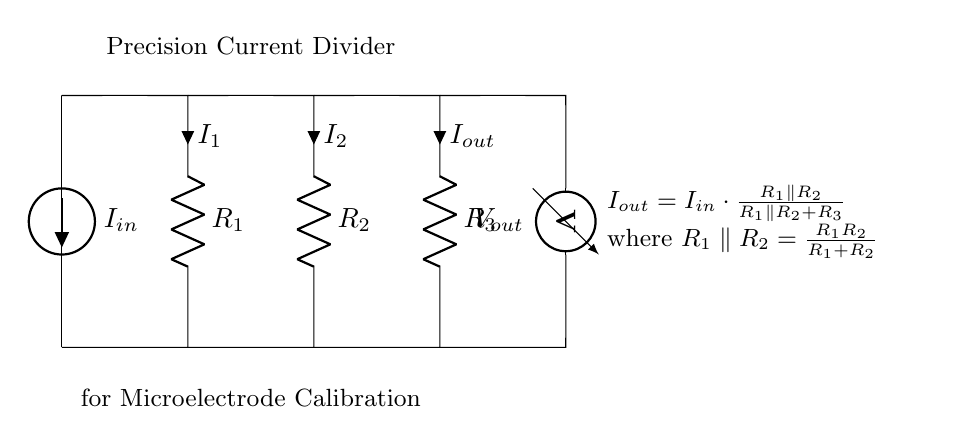What type of current source is used in this circuit? The circuit uses an American current source, as indicated by the symbol and label in the diagram.
Answer: American current source Which components are arranged in parallel in the circuit? R1 and R2 are the resistors that are connected in parallel, as shown by the direct connection between them on the same horizontal line.
Answer: R1 and R2 What is the role of the voltmeter in this circuit? The voltmeter measures the output voltage across resistor R3, providing a reading that is essential for calibration purposes.
Answer: Measures output voltage How does the value of R3 affect the output current? The output current decreases as the value of R3 increases, according to the current divider rule, indicating that R3 acts as a load in the circuit.
Answer: Decreases output current What is the purpose of this precision current divider circuit? This circuit is specifically designed for calibrating microelectrodes used in skin cell electrophysiology experiments by accurately dividing current.
Answer: Calibration of microelectrodes 